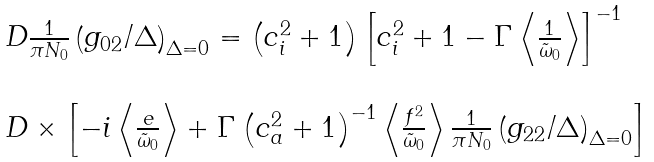Convert formula to latex. <formula><loc_0><loc_0><loc_500><loc_500>\begin{array} { l } \ D \frac { 1 } { \pi N _ { 0 } } \left ( g _ { 0 2 } / \Delta \right ) _ { \Delta = 0 } = \left ( c ^ { 2 } _ { i } + 1 \right ) \left [ c ^ { 2 } _ { i } + 1 - \Gamma \left < \frac { 1 } { \tilde { \omega } _ { 0 } } \right > \right ] ^ { - 1 } \\ \\ \ D \times \left [ - i \left < \frac { e } { \tilde { \omega } _ { 0 } } \right > + \Gamma \left ( c ^ { 2 } _ { a } + 1 \right ) ^ { - 1 } \left < \frac { f ^ { 2 } } { \tilde { \omega } _ { 0 } } \right > \frac { 1 } { \pi N _ { 0 } } \left ( g _ { 2 2 } / \Delta \right ) _ { \Delta = 0 } \right ] \end{array}</formula> 